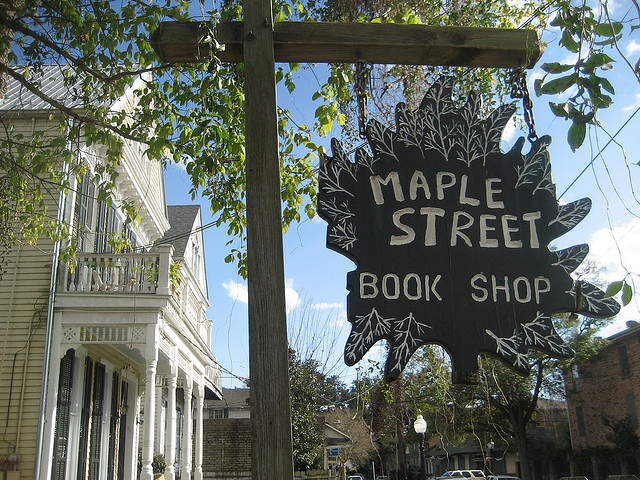Describe the objects in this image and their specific colors. I can see truck in black, gray, darkgray, and ivory tones and car in black, lightgray, gray, and navy tones in this image. 